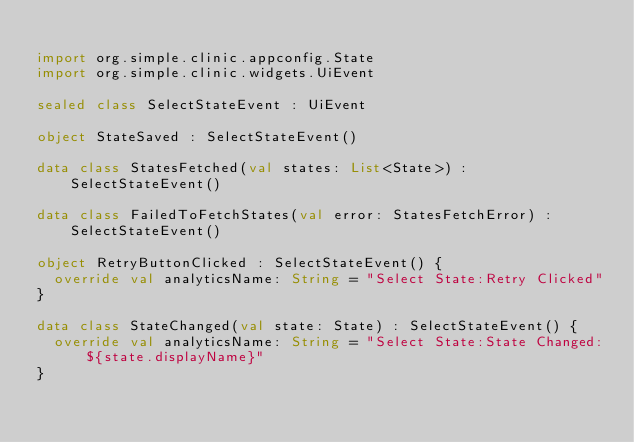<code> <loc_0><loc_0><loc_500><loc_500><_Kotlin_>
import org.simple.clinic.appconfig.State
import org.simple.clinic.widgets.UiEvent

sealed class SelectStateEvent : UiEvent

object StateSaved : SelectStateEvent()

data class StatesFetched(val states: List<State>) : SelectStateEvent()

data class FailedToFetchStates(val error: StatesFetchError) : SelectStateEvent()

object RetryButtonClicked : SelectStateEvent() {
  override val analyticsName: String = "Select State:Retry Clicked"
}

data class StateChanged(val state: State) : SelectStateEvent() {
  override val analyticsName: String = "Select State:State Changed:${state.displayName}"
}
</code> 